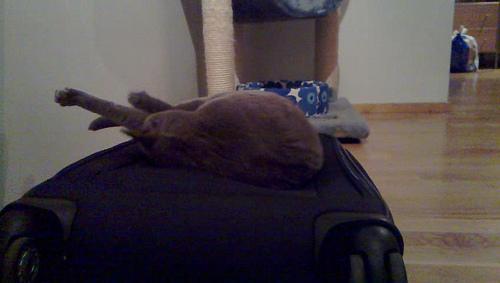What is the cat laying on?
Short answer required. Suitcase. Is there a cat in the house?
Be succinct. Yes. Is the scene inside?
Write a very short answer. Yes. 